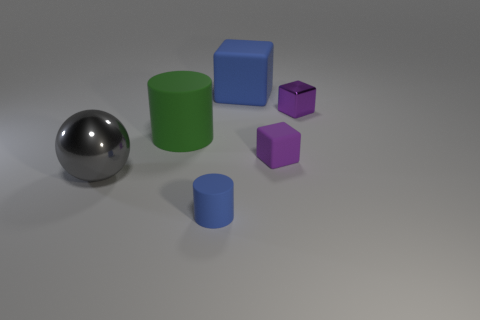What shapes are present in the image? The image depicts geometric shapes consisting of a large sphere, two cubes, and three cylinders. 